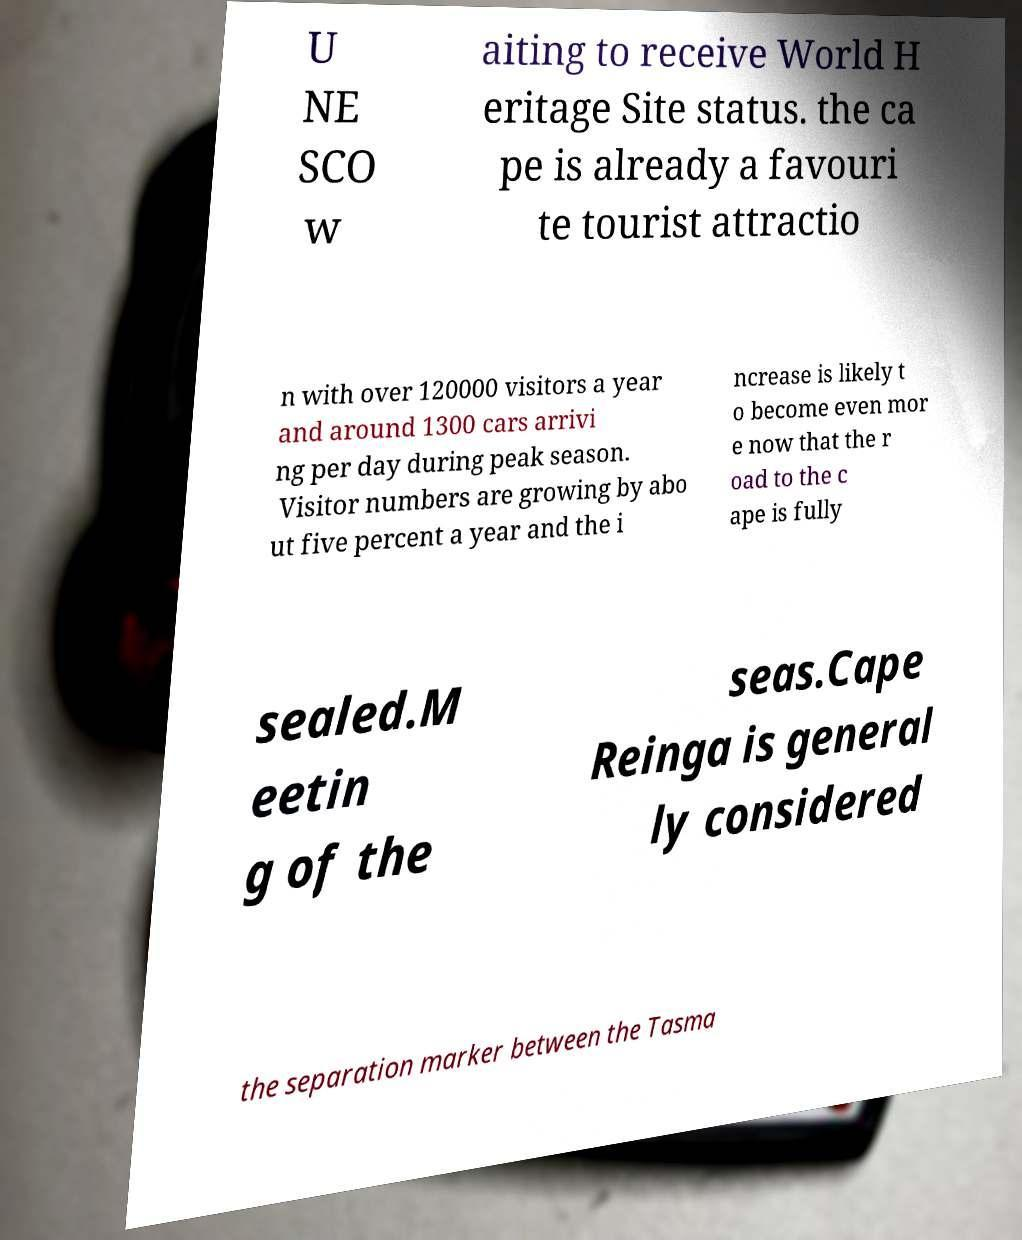Please identify and transcribe the text found in this image. U NE SCO w aiting to receive World H eritage Site status. the ca pe is already a favouri te tourist attractio n with over 120000 visitors a year and around 1300 cars arrivi ng per day during peak season. Visitor numbers are growing by abo ut five percent a year and the i ncrease is likely t o become even mor e now that the r oad to the c ape is fully sealed.M eetin g of the seas.Cape Reinga is general ly considered the separation marker between the Tasma 